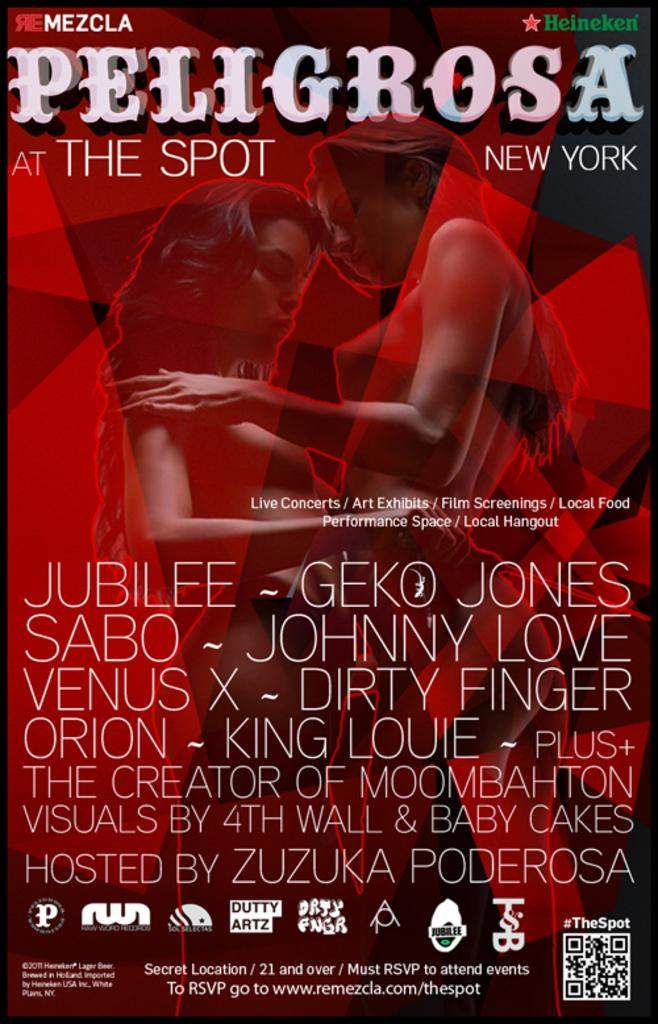What is the main subject of the image? The main subject of the image is a poster. What can be seen at the top of the image? There is text written at the top of the image. What can be seen at the bottom of the image? There is text written at the bottom of the image. What is depicted in the middle of the image? There is a depiction of two women in the middle of the image. What type of nose can be seen on the women depicted in the image? There is no nose visible in the image, as it is a depiction of two women. 